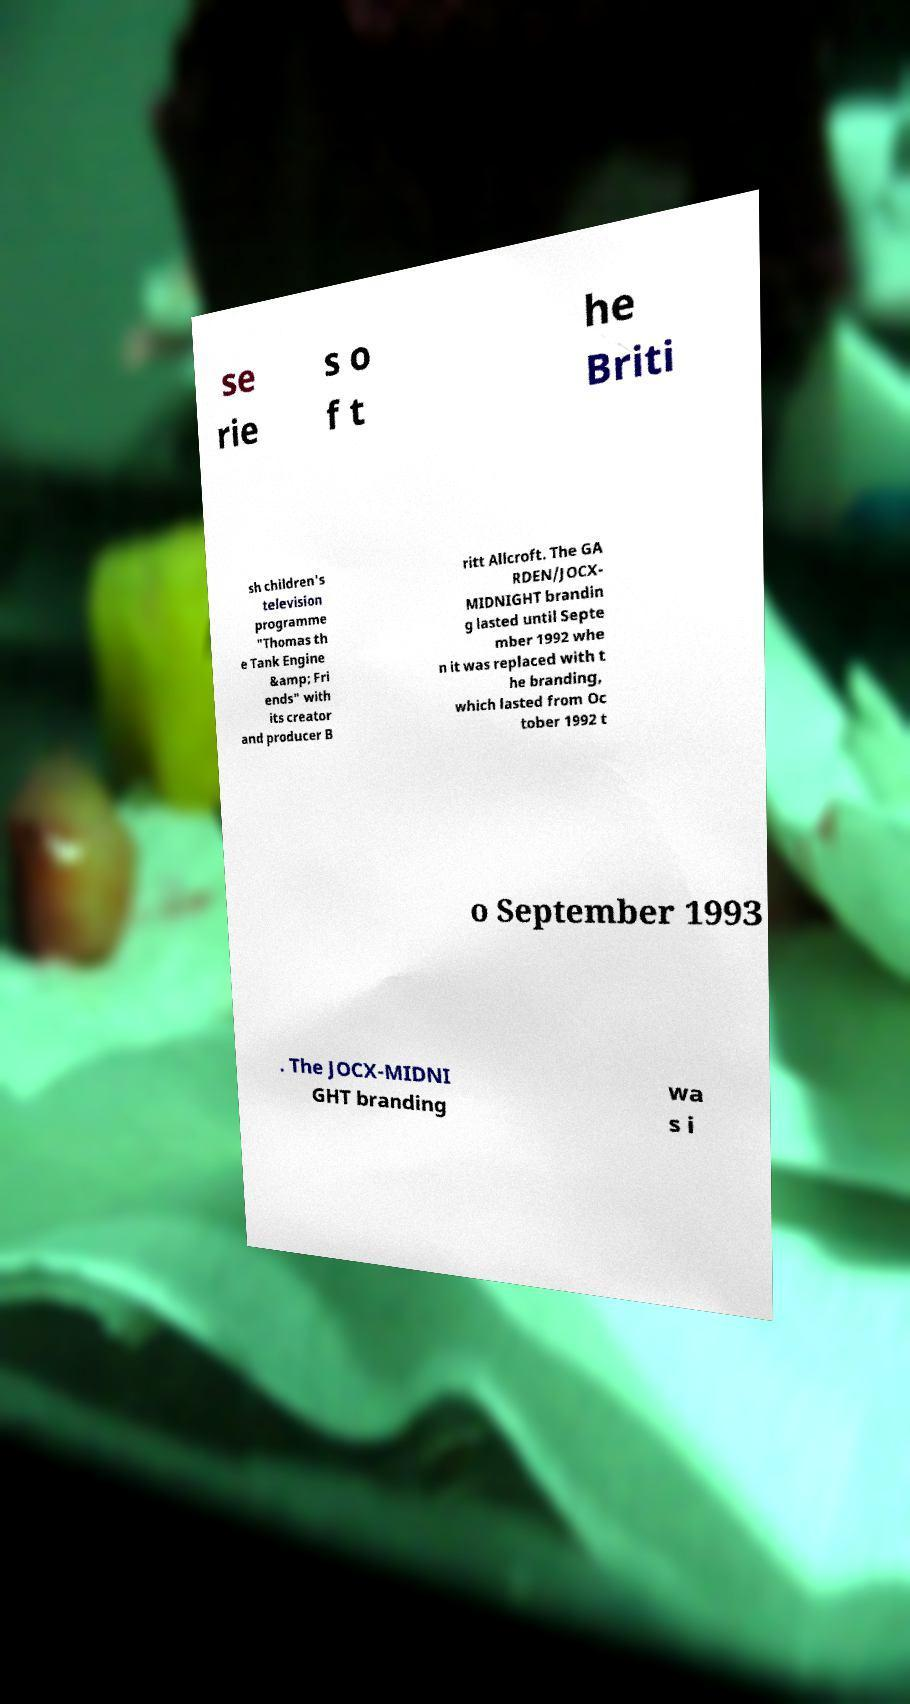For documentation purposes, I need the text within this image transcribed. Could you provide that? se rie s o f t he Briti sh children's television programme "Thomas th e Tank Engine &amp; Fri ends" with its creator and producer B ritt Allcroft. The GA RDEN/JOCX- MIDNIGHT brandin g lasted until Septe mber 1992 whe n it was replaced with t he branding, which lasted from Oc tober 1992 t o September 1993 . The JOCX-MIDNI GHT branding wa s i 